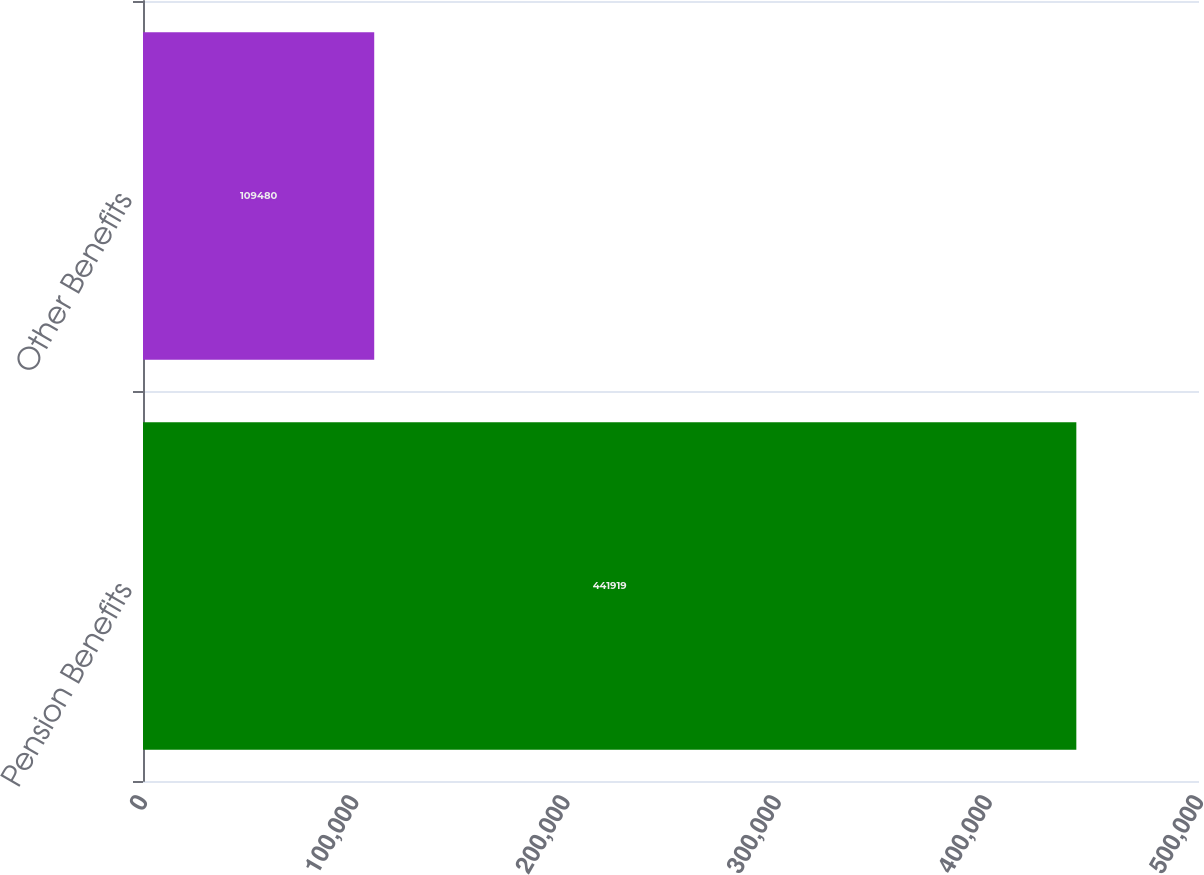Convert chart. <chart><loc_0><loc_0><loc_500><loc_500><bar_chart><fcel>Pension Benefits<fcel>Other Benefits<nl><fcel>441919<fcel>109480<nl></chart> 